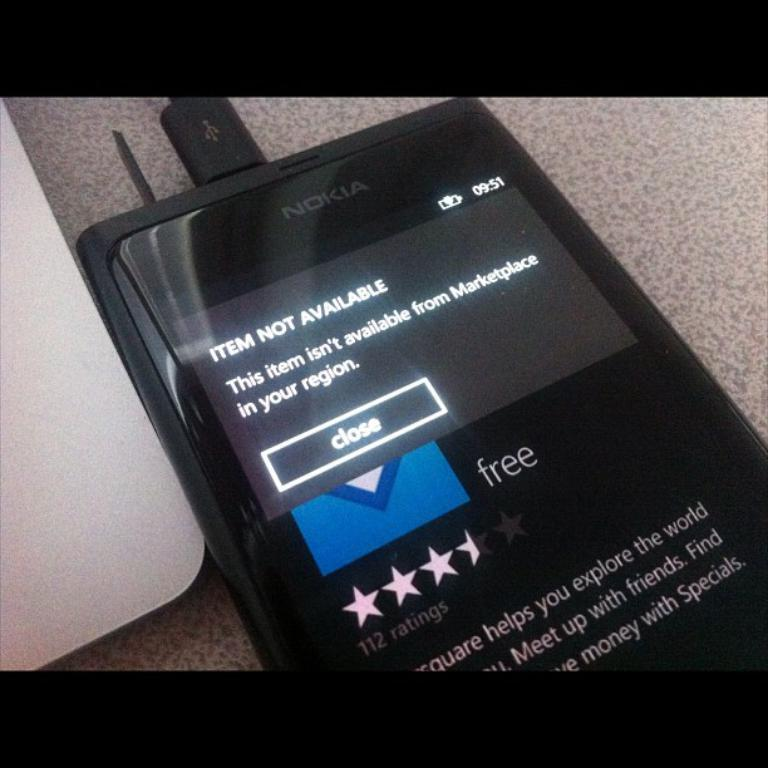Provide a one-sentence caption for the provided image. A black Nokia brand cellphone with the display screen displaying Item Not Available and a close button. 